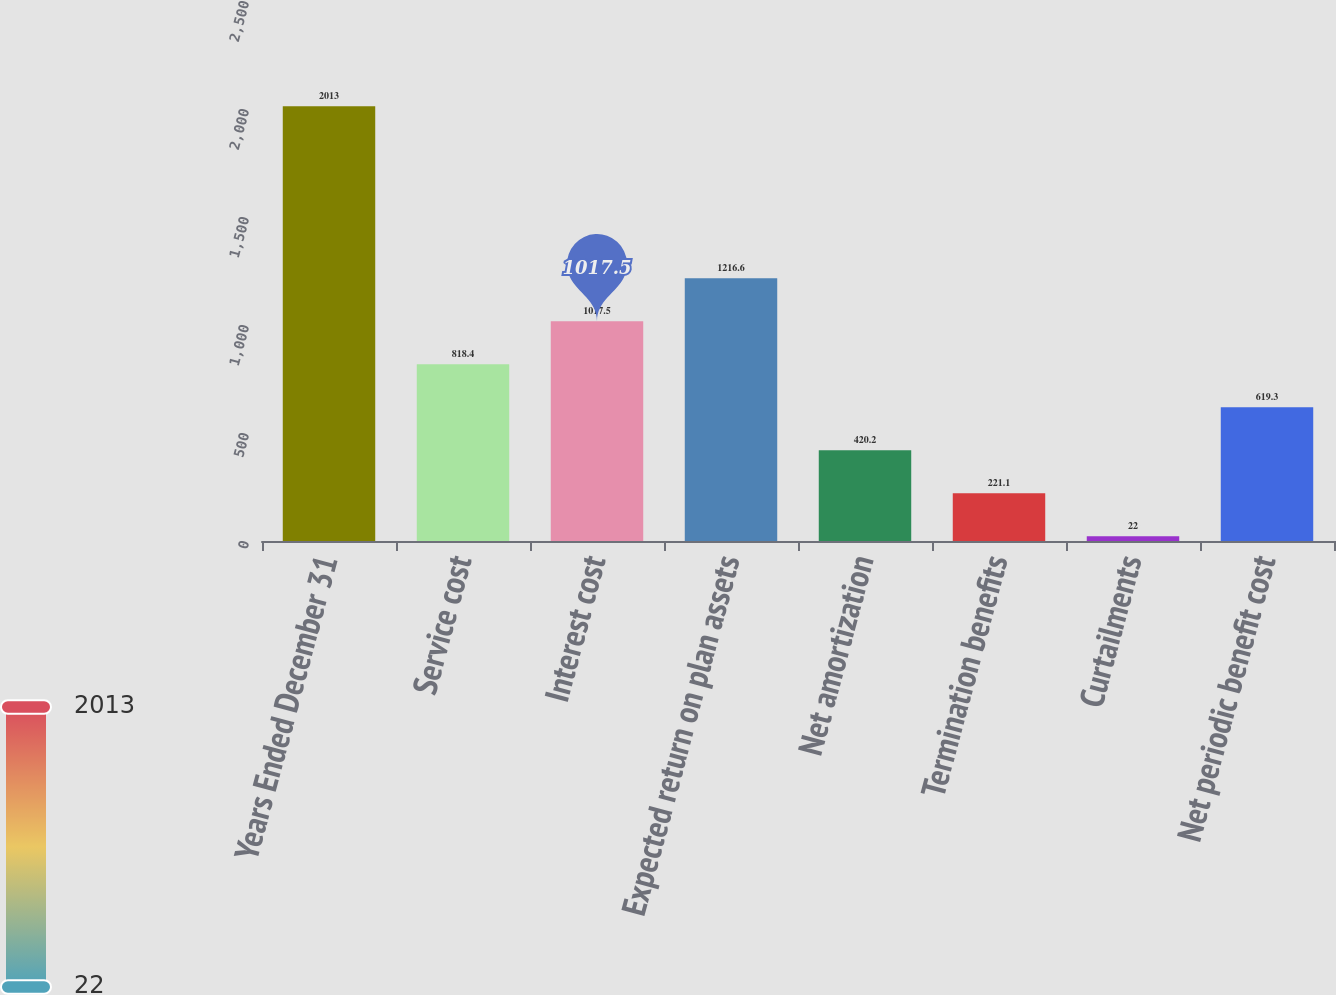Convert chart to OTSL. <chart><loc_0><loc_0><loc_500><loc_500><bar_chart><fcel>Years Ended December 31<fcel>Service cost<fcel>Interest cost<fcel>Expected return on plan assets<fcel>Net amortization<fcel>Termination benefits<fcel>Curtailments<fcel>Net periodic benefit cost<nl><fcel>2013<fcel>818.4<fcel>1017.5<fcel>1216.6<fcel>420.2<fcel>221.1<fcel>22<fcel>619.3<nl></chart> 